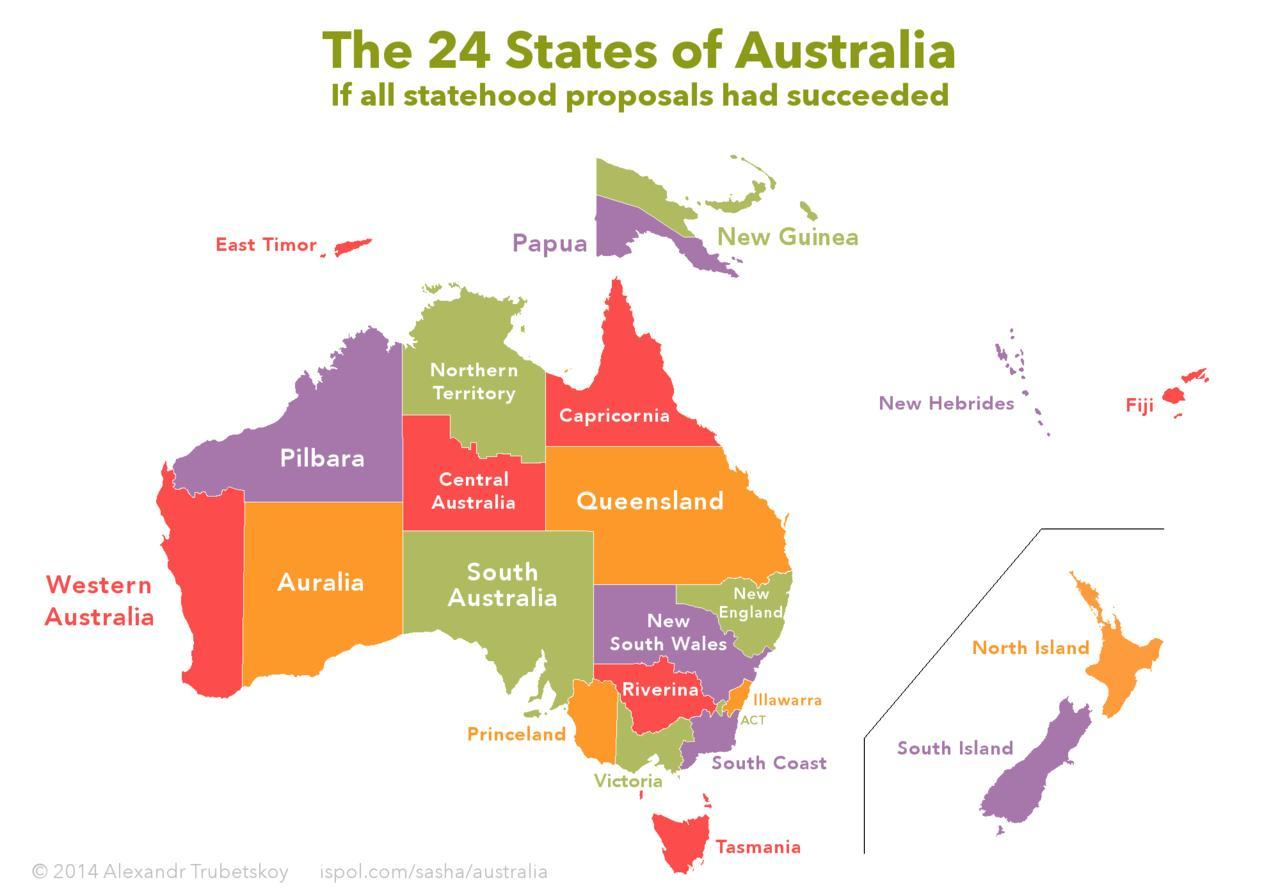which state in is between norther territory and south australia
Answer the question with a short phrase. central australia what is the colour of fiji island, red or purple red which state is above papua new guinea which island is to the left of papua east timor which state comes in between western australia and south australia auralia which island is shown in orange north island 